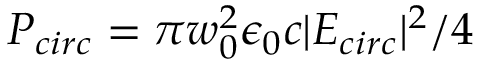Convert formula to latex. <formula><loc_0><loc_0><loc_500><loc_500>P _ { c i r c } = \pi w _ { 0 } ^ { 2 } \epsilon _ { 0 } c | E _ { c i r c } | ^ { 2 } / 4</formula> 